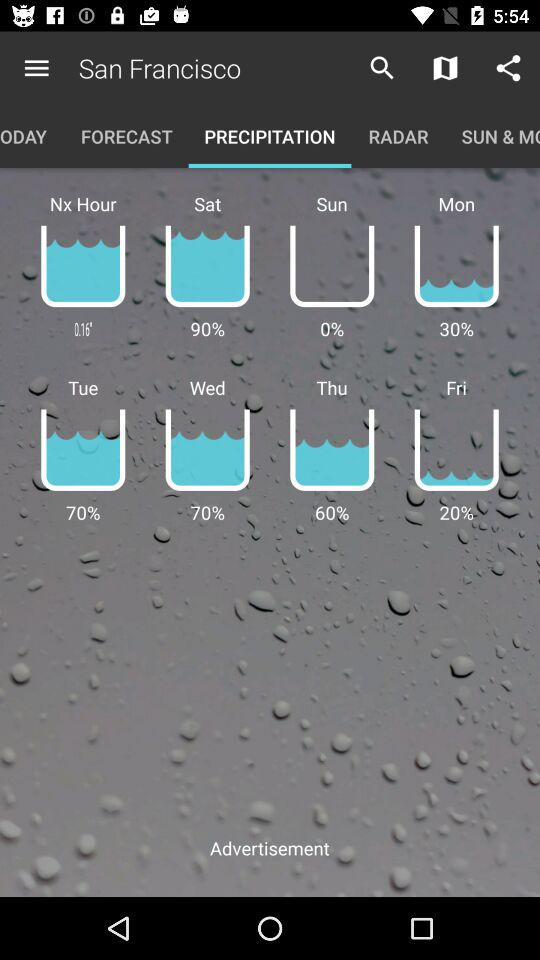Which tab is selected? The selected tab is precipitation. 